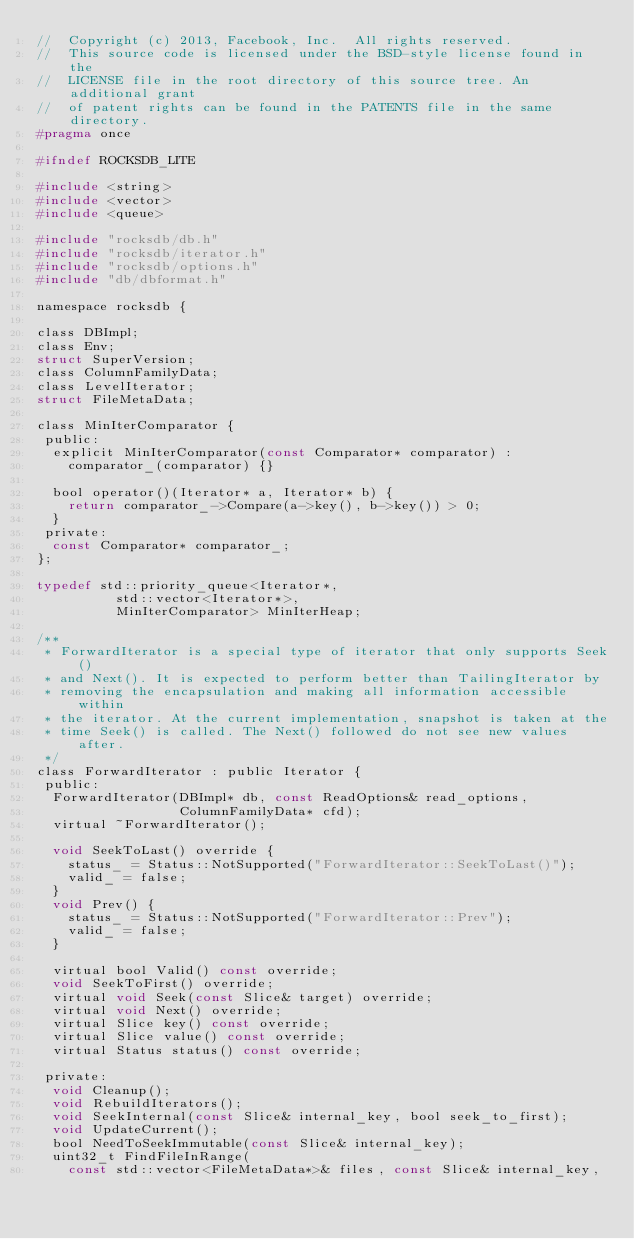Convert code to text. <code><loc_0><loc_0><loc_500><loc_500><_C_>//  Copyright (c) 2013, Facebook, Inc.  All rights reserved.
//  This source code is licensed under the BSD-style license found in the
//  LICENSE file in the root directory of this source tree. An additional grant
//  of patent rights can be found in the PATENTS file in the same directory.
#pragma once

#ifndef ROCKSDB_LITE

#include <string>
#include <vector>
#include <queue>

#include "rocksdb/db.h"
#include "rocksdb/iterator.h"
#include "rocksdb/options.h"
#include "db/dbformat.h"

namespace rocksdb {

class DBImpl;
class Env;
struct SuperVersion;
class ColumnFamilyData;
class LevelIterator;
struct FileMetaData;

class MinIterComparator {
 public:
  explicit MinIterComparator(const Comparator* comparator) :
    comparator_(comparator) {}

  bool operator()(Iterator* a, Iterator* b) {
    return comparator_->Compare(a->key(), b->key()) > 0;
  }
 private:
  const Comparator* comparator_;
};

typedef std::priority_queue<Iterator*,
          std::vector<Iterator*>,
          MinIterComparator> MinIterHeap;

/**
 * ForwardIterator is a special type of iterator that only supports Seek()
 * and Next(). It is expected to perform better than TailingIterator by
 * removing the encapsulation and making all information accessible within
 * the iterator. At the current implementation, snapshot is taken at the
 * time Seek() is called. The Next() followed do not see new values after.
 */
class ForwardIterator : public Iterator {
 public:
  ForwardIterator(DBImpl* db, const ReadOptions& read_options,
                  ColumnFamilyData* cfd);
  virtual ~ForwardIterator();

  void SeekToLast() override {
    status_ = Status::NotSupported("ForwardIterator::SeekToLast()");
    valid_ = false;
  }
  void Prev() {
    status_ = Status::NotSupported("ForwardIterator::Prev");
    valid_ = false;
  }

  virtual bool Valid() const override;
  void SeekToFirst() override;
  virtual void Seek(const Slice& target) override;
  virtual void Next() override;
  virtual Slice key() const override;
  virtual Slice value() const override;
  virtual Status status() const override;

 private:
  void Cleanup();
  void RebuildIterators();
  void SeekInternal(const Slice& internal_key, bool seek_to_first);
  void UpdateCurrent();
  bool NeedToSeekImmutable(const Slice& internal_key);
  uint32_t FindFileInRange(
    const std::vector<FileMetaData*>& files, const Slice& internal_key,</code> 